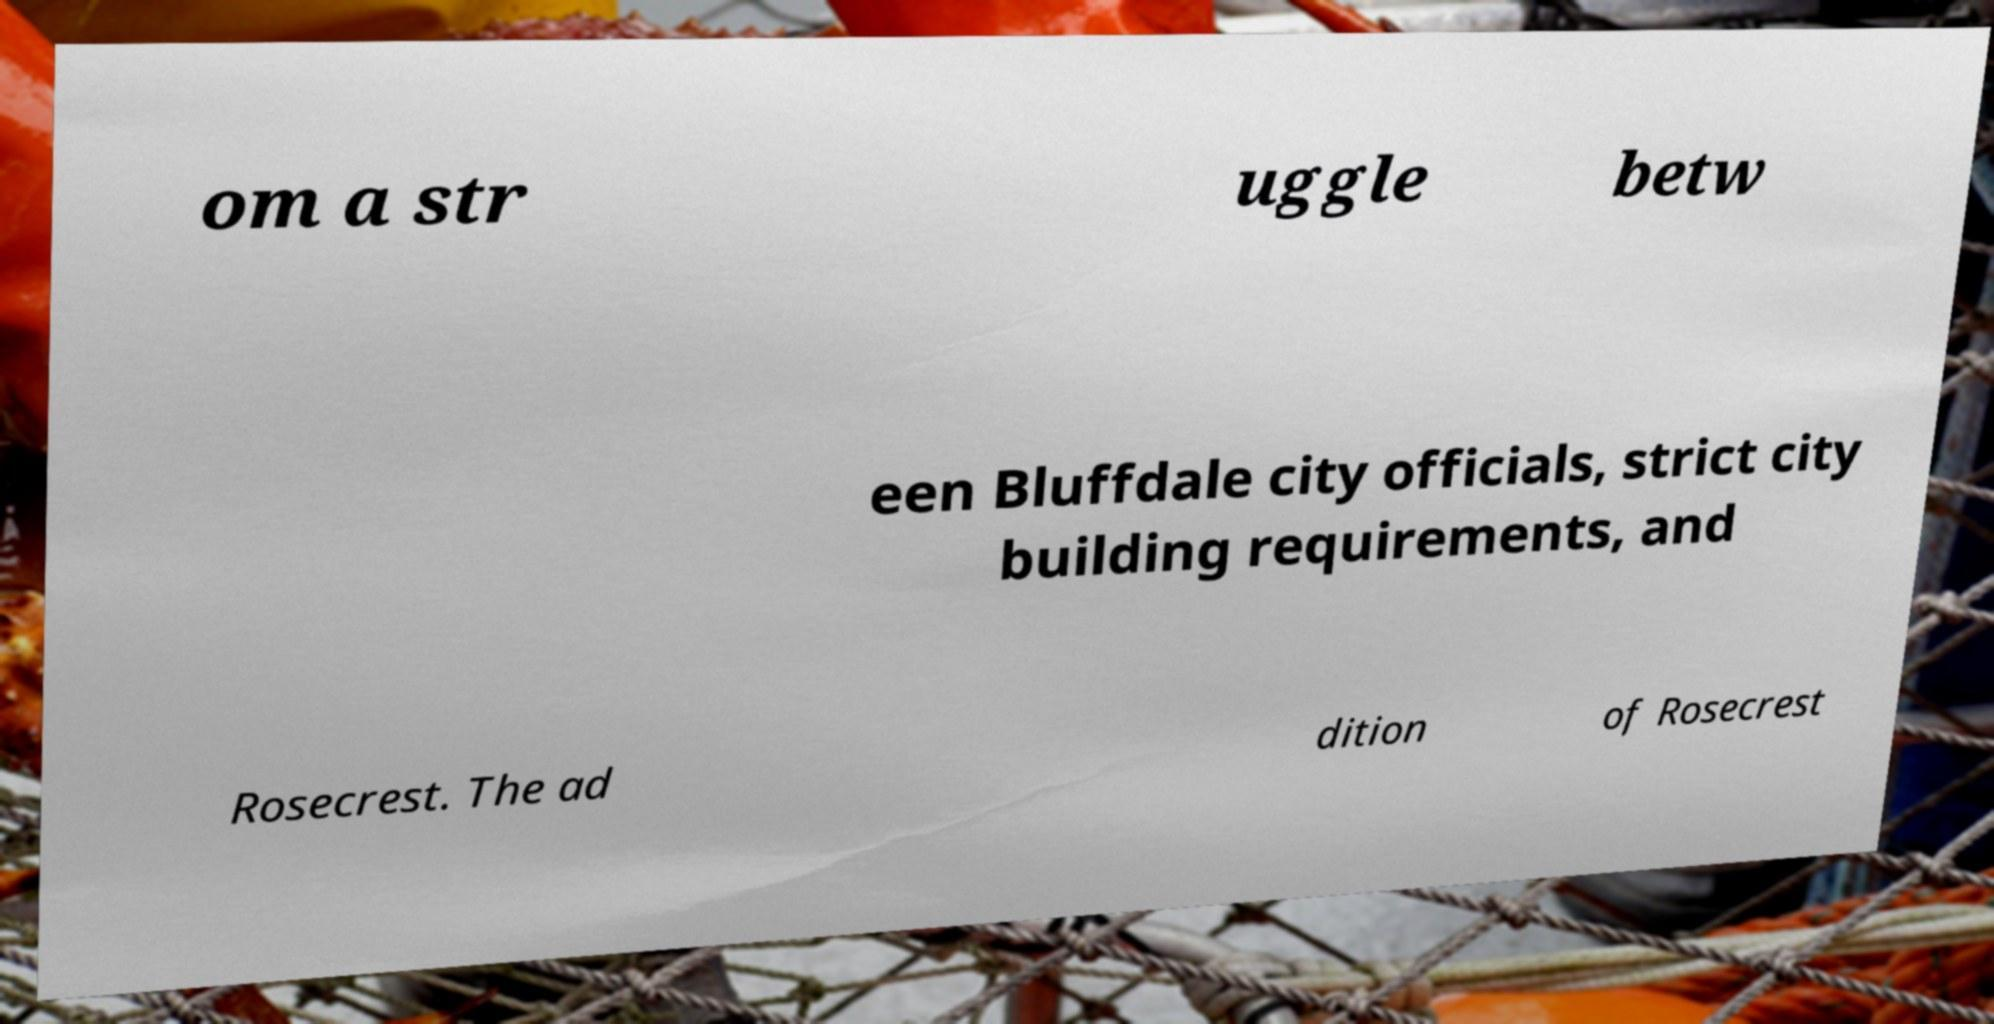Could you assist in decoding the text presented in this image and type it out clearly? om a str uggle betw een Bluffdale city officials, strict city building requirements, and Rosecrest. The ad dition of Rosecrest 